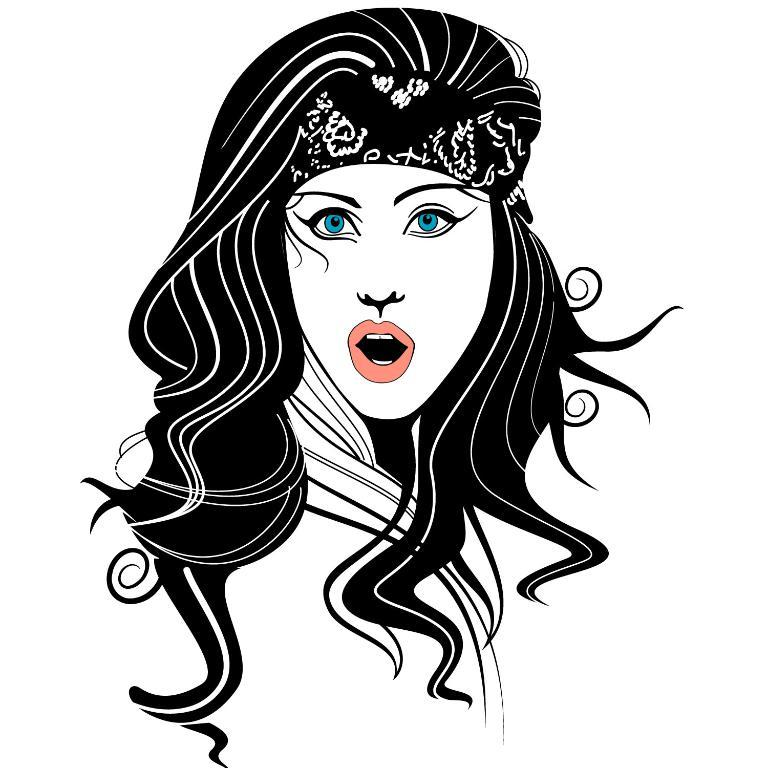What is the main subject of the image? There is a painting in the image. What is depicted in the painting? The painting depicts a woman. What color is the background of the painting? The background of the painting is white. What is the opinion of the woman in the painting about the latest fashion trends? The image does not provide any information about the woman's opinion on fashion trends, as it only shows a painting of her. 